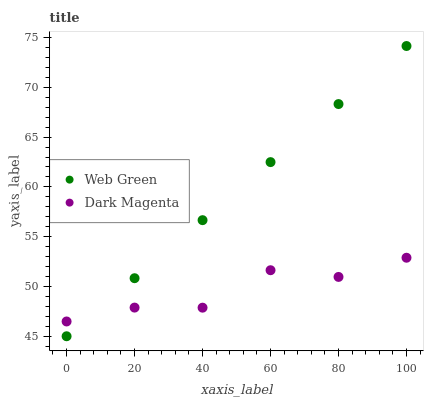Does Dark Magenta have the minimum area under the curve?
Answer yes or no. Yes. Does Web Green have the maximum area under the curve?
Answer yes or no. Yes. Does Web Green have the minimum area under the curve?
Answer yes or no. No. Is Web Green the smoothest?
Answer yes or no. Yes. Is Dark Magenta the roughest?
Answer yes or no. Yes. Is Web Green the roughest?
Answer yes or no. No. Does Web Green have the lowest value?
Answer yes or no. Yes. Does Web Green have the highest value?
Answer yes or no. Yes. Does Web Green intersect Dark Magenta?
Answer yes or no. Yes. Is Web Green less than Dark Magenta?
Answer yes or no. No. Is Web Green greater than Dark Magenta?
Answer yes or no. No. 